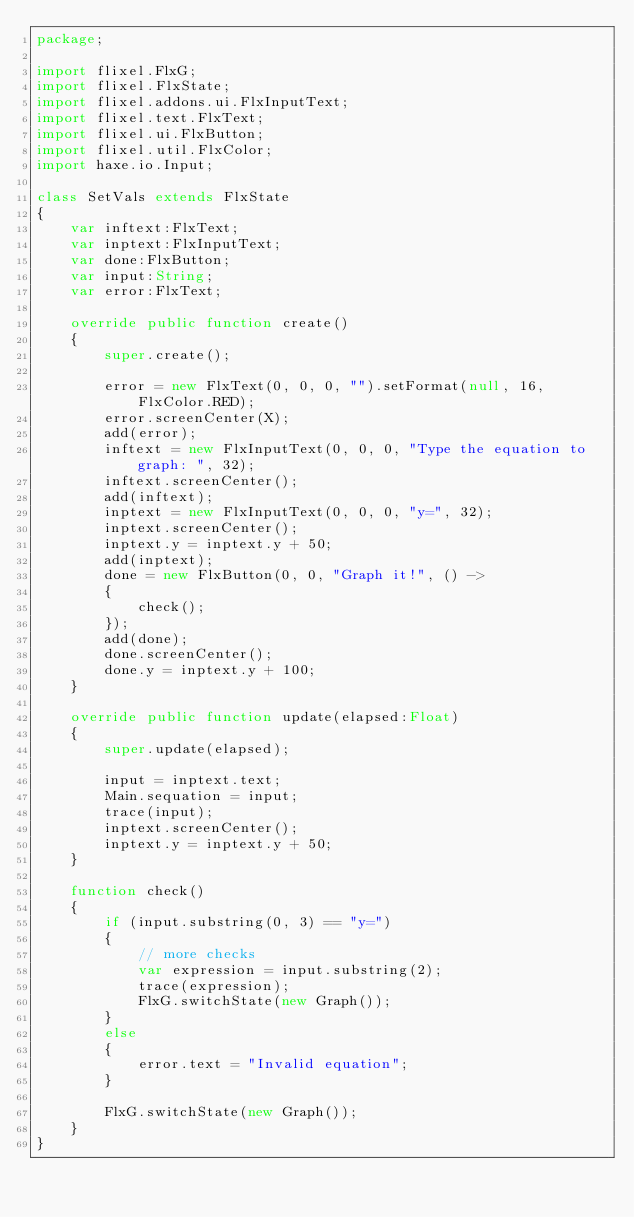<code> <loc_0><loc_0><loc_500><loc_500><_Haxe_>package;

import flixel.FlxG;
import flixel.FlxState;
import flixel.addons.ui.FlxInputText;
import flixel.text.FlxText;
import flixel.ui.FlxButton;
import flixel.util.FlxColor;
import haxe.io.Input;

class SetVals extends FlxState
{
	var inftext:FlxText;
	var inptext:FlxInputText;
	var done:FlxButton;
	var input:String;
	var error:FlxText;

	override public function create()
	{
		super.create();

		error = new FlxText(0, 0, 0, "").setFormat(null, 16, FlxColor.RED);
		error.screenCenter(X);
		add(error);
		inftext = new FlxInputText(0, 0, 0, "Type the equation to graph: ", 32);
		inftext.screenCenter();
		add(inftext);
		inptext = new FlxInputText(0, 0, 0, "y=", 32);
		inptext.screenCenter();
		inptext.y = inptext.y + 50;
		add(inptext);
		done = new FlxButton(0, 0, "Graph it!", () ->
		{
			check();
		});
		add(done);
		done.screenCenter();
		done.y = inptext.y + 100;
	}

	override public function update(elapsed:Float)
	{
		super.update(elapsed);

		input = inptext.text;
		Main.sequation = input;
		trace(input);
		inptext.screenCenter();
		inptext.y = inptext.y + 50;
	}

	function check()
	{
		if (input.substring(0, 3) == "y=")
		{
			// more checks
			var expression = input.substring(2);
			trace(expression);
			FlxG.switchState(new Graph());
		}
		else
		{
			error.text = "Invalid equation";
		}

		FlxG.switchState(new Graph());
	}
}
</code> 